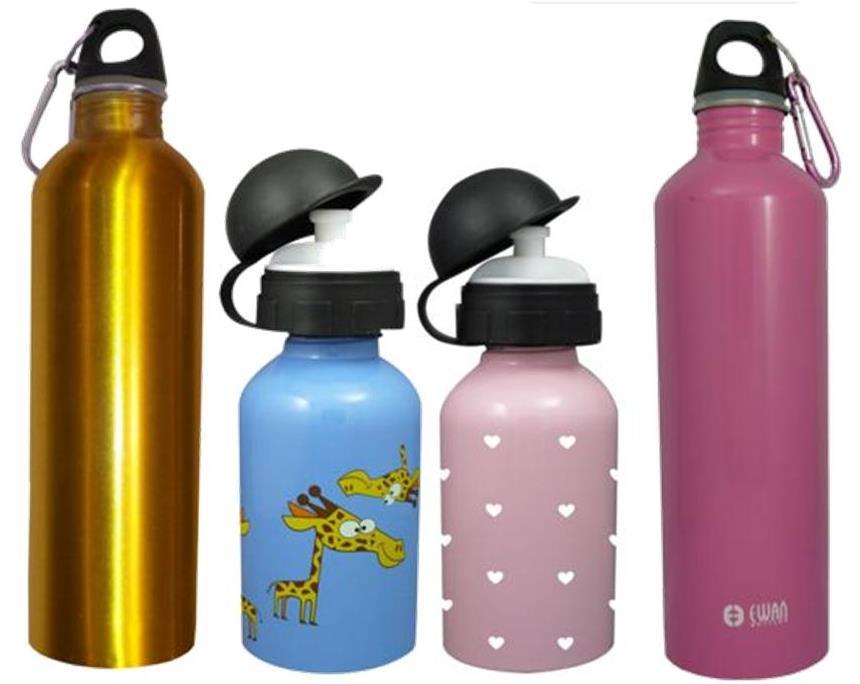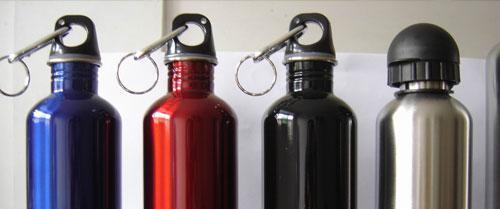The first image is the image on the left, the second image is the image on the right. Considering the images on both sides, is "The left image include blue, lavender and purple water bottles, and the right image includes silver, red and blue bottles, as well as three 'loops' on bottles." valid? Answer yes or no. Yes. The first image is the image on the left, the second image is the image on the right. Given the left and right images, does the statement "The left and right image contains the same number of bottles." hold true? Answer yes or no. Yes. 